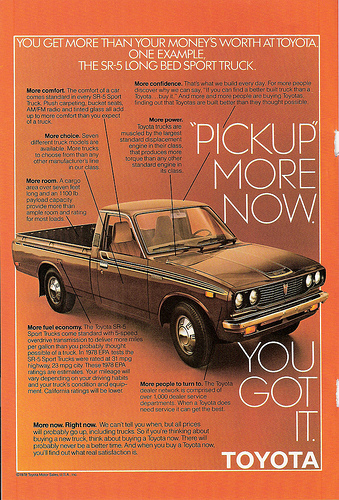<image>
Can you confirm if the words is on the paper? Yes. Looking at the image, I can see the words is positioned on top of the paper, with the paper providing support. 